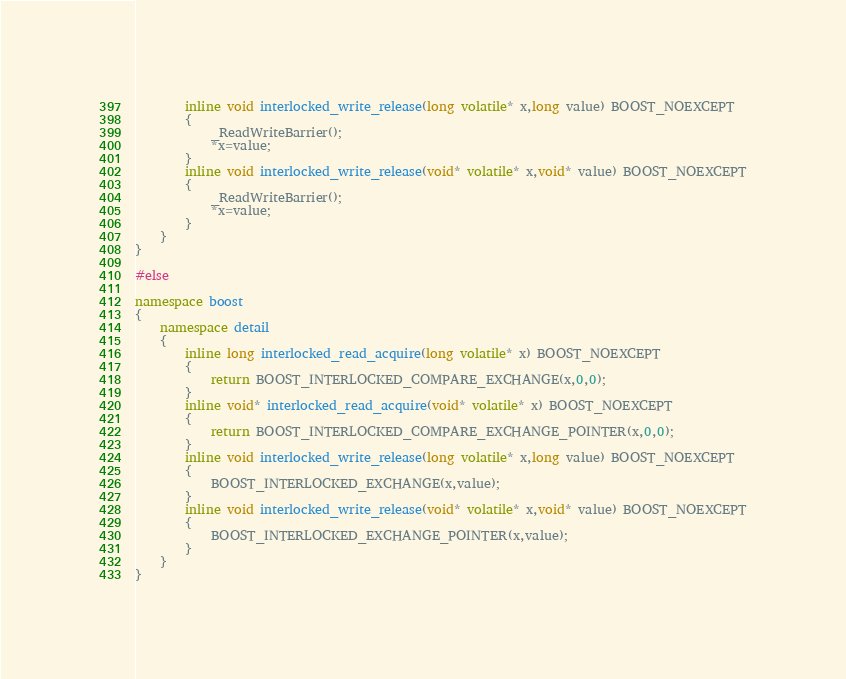Convert code to text. <code><loc_0><loc_0><loc_500><loc_500><_C++_>        inline void interlocked_write_release(long volatile* x,long value) BOOST_NOEXCEPT
        {
            _ReadWriteBarrier();
            *x=value;
        }
        inline void interlocked_write_release(void* volatile* x,void* value) BOOST_NOEXCEPT
        {
            _ReadWriteBarrier();
            *x=value;
        }
    }
}

#else

namespace boost
{
    namespace detail
    {
        inline long interlocked_read_acquire(long volatile* x) BOOST_NOEXCEPT
        {
            return BOOST_INTERLOCKED_COMPARE_EXCHANGE(x,0,0);
        }
        inline void* interlocked_read_acquire(void* volatile* x) BOOST_NOEXCEPT
        {
            return BOOST_INTERLOCKED_COMPARE_EXCHANGE_POINTER(x,0,0);
        }
        inline void interlocked_write_release(long volatile* x,long value) BOOST_NOEXCEPT
        {
            BOOST_INTERLOCKED_EXCHANGE(x,value);
        }
        inline void interlocked_write_release(void* volatile* x,void* value) BOOST_NOEXCEPT
        {
            BOOST_INTERLOCKED_EXCHANGE_POINTER(x,value);
        }
    }
}
</code> 